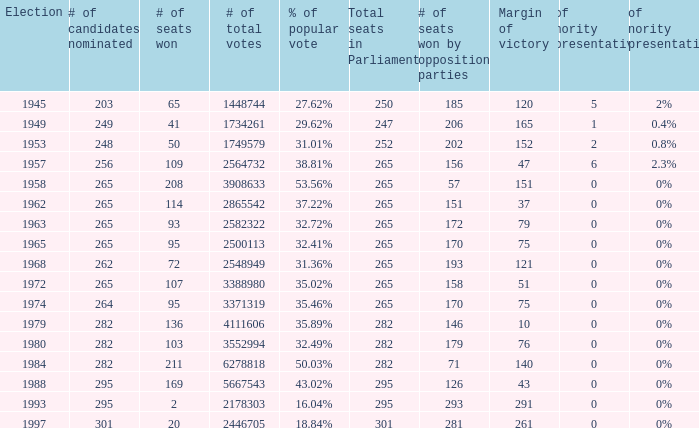What year was the election when the # of seats won was 65? 1945.0. 